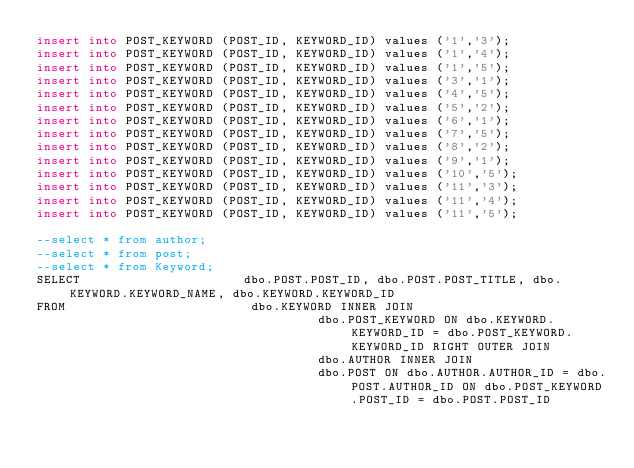<code> <loc_0><loc_0><loc_500><loc_500><_SQL_>insert into POST_KEYWORD (POST_ID, KEYWORD_ID) values ('1','3');
insert into POST_KEYWORD (POST_ID, KEYWORD_ID) values ('1','4');
insert into POST_KEYWORD (POST_ID, KEYWORD_ID) values ('1','5');
insert into POST_KEYWORD (POST_ID, KEYWORD_ID) values ('3','1');
insert into POST_KEYWORD (POST_ID, KEYWORD_ID) values ('4','5');
insert into POST_KEYWORD (POST_ID, KEYWORD_ID) values ('5','2');
insert into POST_KEYWORD (POST_ID, KEYWORD_ID) values ('6','1');
insert into POST_KEYWORD (POST_ID, KEYWORD_ID) values ('7','5');
insert into POST_KEYWORD (POST_ID, KEYWORD_ID) values ('8','2');
insert into POST_KEYWORD (POST_ID, KEYWORD_ID) values ('9','1');
insert into POST_KEYWORD (POST_ID, KEYWORD_ID) values ('10','5');
insert into POST_KEYWORD (POST_ID, KEYWORD_ID) values ('11','3');
insert into POST_KEYWORD (POST_ID, KEYWORD_ID) values ('11','4');
insert into POST_KEYWORD (POST_ID, KEYWORD_ID) values ('11','5');

--select * from author;
--select * from post;
--select * from Keyword;
SELECT                      dbo.POST.POST_ID, dbo.POST.POST_TITLE, dbo.KEYWORD.KEYWORD_NAME, dbo.KEYWORD.KEYWORD_ID
FROM                         dbo.KEYWORD INNER JOIN
                                      dbo.POST_KEYWORD ON dbo.KEYWORD.KEYWORD_ID = dbo.POST_KEYWORD.KEYWORD_ID RIGHT OUTER JOIN
                                      dbo.AUTHOR INNER JOIN
                                      dbo.POST ON dbo.AUTHOR.AUTHOR_ID = dbo.POST.AUTHOR_ID ON dbo.POST_KEYWORD.POST_ID = dbo.POST.POST_ID
</code> 